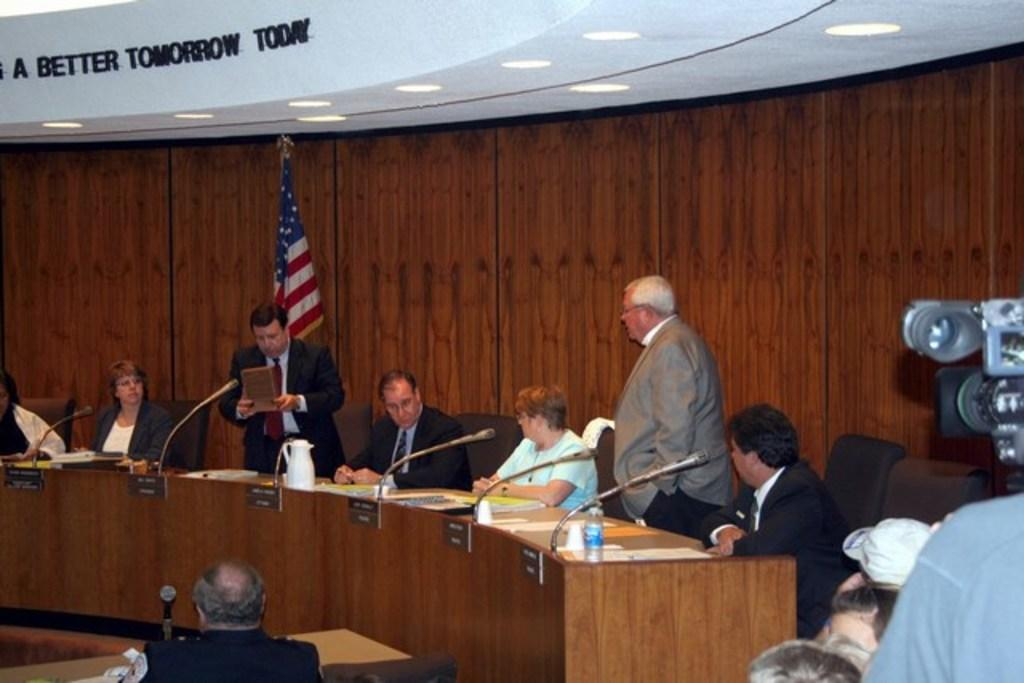How many people are in the image? There is a group of people in the image. What are the people doing in the image? The people are sitting on chairs. Where are the chairs located in relation to the table? The chairs are in front of a table. What can be seen in the background of the image? There is a flag on a pole in the background of the image. What type of clouds can be seen in the image? There are no clouds visible in the image. How many ducks are present in the image? There are no ducks present in the image. 